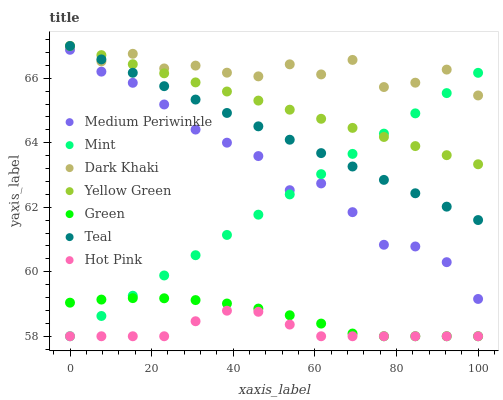Does Hot Pink have the minimum area under the curve?
Answer yes or no. Yes. Does Dark Khaki have the maximum area under the curve?
Answer yes or no. Yes. Does Medium Periwinkle have the minimum area under the curve?
Answer yes or no. No. Does Medium Periwinkle have the maximum area under the curve?
Answer yes or no. No. Is Mint the smoothest?
Answer yes or no. Yes. Is Dark Khaki the roughest?
Answer yes or no. Yes. Is Hot Pink the smoothest?
Answer yes or no. No. Is Hot Pink the roughest?
Answer yes or no. No. Does Hot Pink have the lowest value?
Answer yes or no. Yes. Does Medium Periwinkle have the lowest value?
Answer yes or no. No. Does Teal have the highest value?
Answer yes or no. Yes. Does Medium Periwinkle have the highest value?
Answer yes or no. No. Is Medium Periwinkle less than Teal?
Answer yes or no. Yes. Is Medium Periwinkle greater than Green?
Answer yes or no. Yes. Does Teal intersect Mint?
Answer yes or no. Yes. Is Teal less than Mint?
Answer yes or no. No. Is Teal greater than Mint?
Answer yes or no. No. Does Medium Periwinkle intersect Teal?
Answer yes or no. No. 